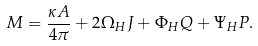Convert formula to latex. <formula><loc_0><loc_0><loc_500><loc_500>M = \frac { \kappa A } { 4 \pi } + 2 \Omega _ { H } J + \Phi _ { H } Q + \Psi _ { H } P .</formula> 